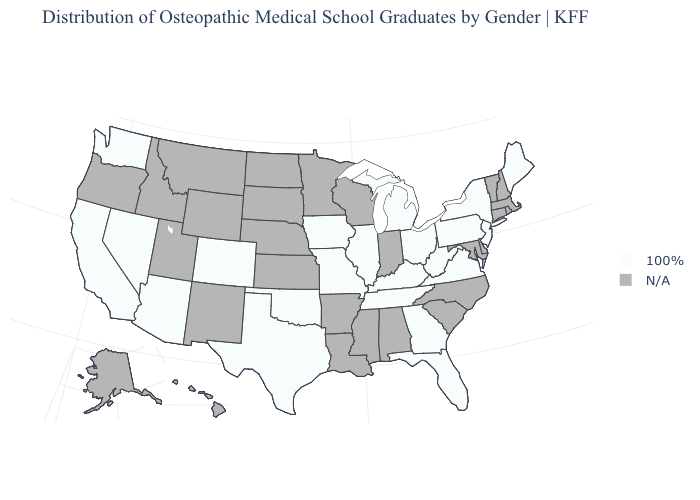How many symbols are there in the legend?
Concise answer only. 2. What is the value of Indiana?
Quick response, please. N/A. What is the lowest value in the West?
Write a very short answer. 100%. What is the value of Vermont?
Write a very short answer. N/A. Is the legend a continuous bar?
Be succinct. No. What is the lowest value in the USA?
Short answer required. 100%. Does the first symbol in the legend represent the smallest category?
Give a very brief answer. Yes. What is the value of Tennessee?
Write a very short answer. 100%. What is the value of California?
Be succinct. 100%. What is the value of Utah?
Be succinct. N/A. What is the highest value in the South ?
Quick response, please. 100%. What is the value of California?
Give a very brief answer. 100%. What is the lowest value in the West?
Be succinct. 100%. 